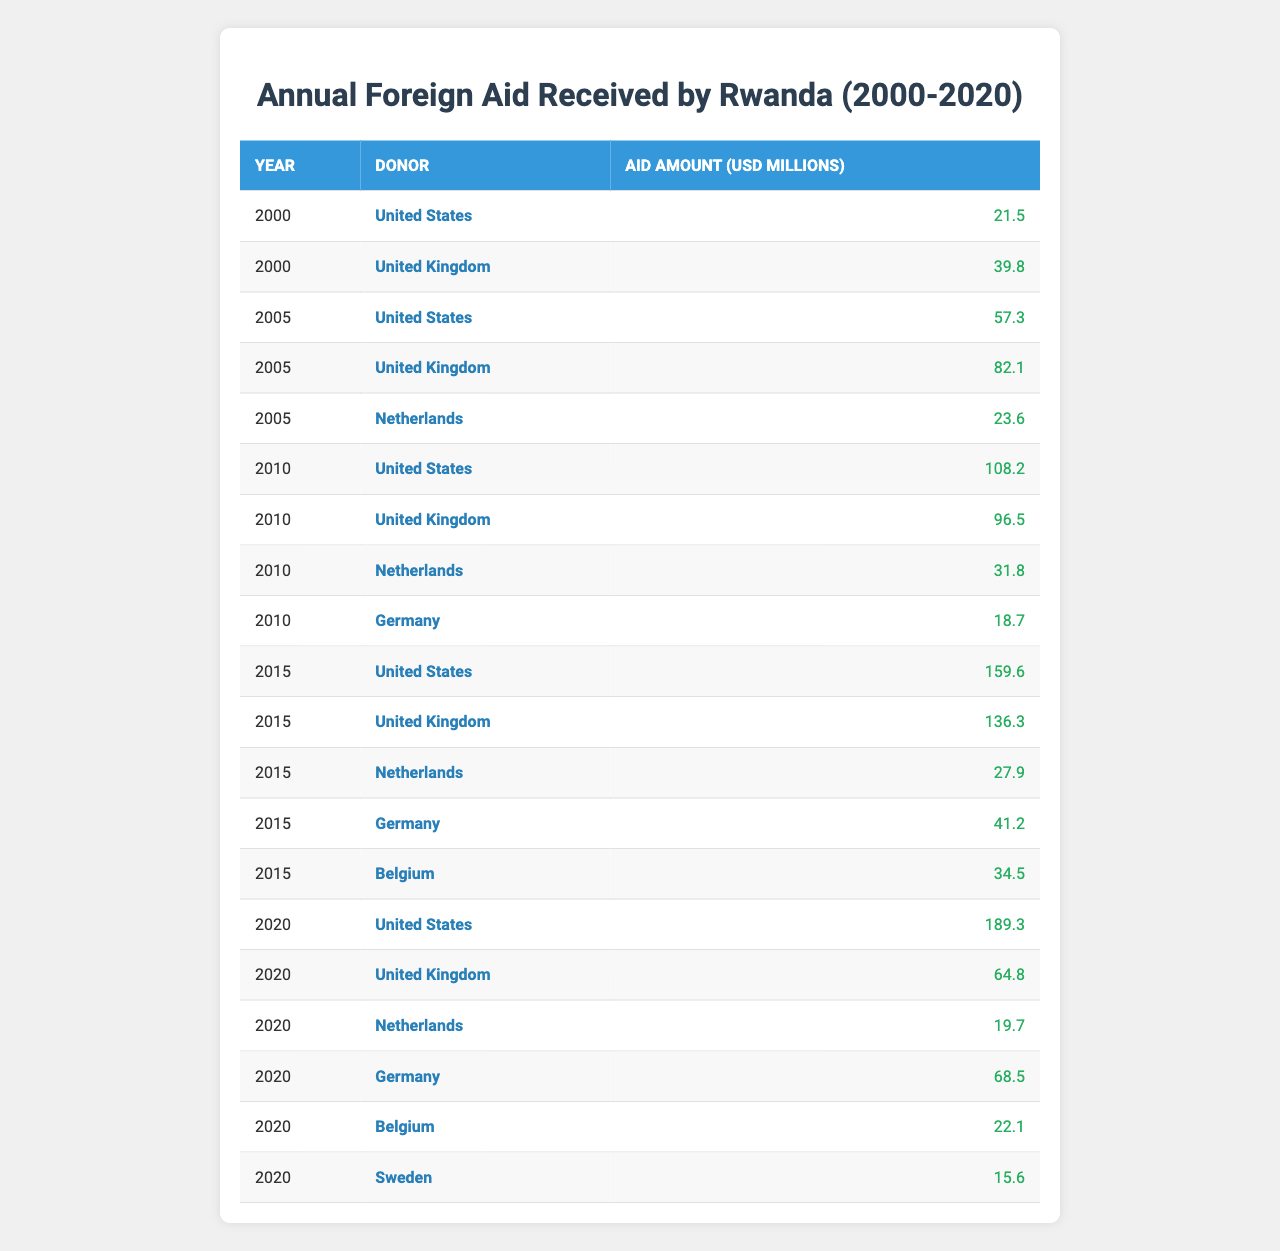What was the total foreign aid received from the United States in 2015? In 2015, the aid received from the United States was 159.6 million USD.
Answer: 159.6 million USD Which country provided the highest aid amount in 2020? In 2020, the highest aid amount was provided by the United States, which contributed 189.3 million USD.
Answer: United States How much foreign aid did Germany provide in 2010? Germany provided 18.7 million USD in aid to Rwanda in 2010.
Answer: 18.7 million USD What is the combined foreign aid amount from the United Kingdom in 2015 and 2020? The United Kingdom provided 136.3 million USD in 2015 and 64.8 million USD in 2020. The combined total is 136.3 + 64.8 = 201.1 million USD.
Answer: 201.1 million USD Is it true that the United Kingdom provided more aid in 2015 than in 2010? Yes, in 2015 the United Kingdom provided 136.3 million USD, while in 2010 they provided 96.5 million USD, which is more.
Answer: Yes What was the average foreign aid received by Rwanda from the Netherlands during the years 2005, 2010, and 2015? The aid amounts from the Netherlands were 23.6 million USD in 2005, 31.8 million USD in 2010, and 27.9 million USD in 2015. The average is (23.6 + 31.8 + 27.9) / 3 = 27.8 million USD.
Answer: 27.8 million USD How much total aid did Belgium provide in the years 2015 and 2020? Belgium provided 34.5 million USD in 2015 and 22.1 million USD in 2020. The total is 34.5 + 22.1 = 56.6 million USD.
Answer: 56.6 million USD Which donor country consistently provided aid every five years from 2000 to 2020? The United States was the donor country that consistently provided aid in 2000, 2005, 2010, 2015, and 2020.
Answer: United States What was the difference in the aid amounts provided by Germany from 2015 to 2020? Germany provided 41.2 million USD in 2015 and 68.5 million USD in 2020. The difference is 68.5 - 41.2 = 27.3 million USD.
Answer: 27.3 million USD What percentage of the total aid in 2010 came from the United States? The total aid received in 2010 was 108.2 million USD from the United States, 96.5 million USD from the United Kingdom, 31.8 million USD from the Netherlands, and 18.7 million USD from Germany, which totals to 108.2 + 96.5 + 31.8 + 18.7 = 255.2 million USD. The percentage from the United States is (108.2 / 255.2) * 100 ≈ 42.4%.
Answer: ~42.4% 